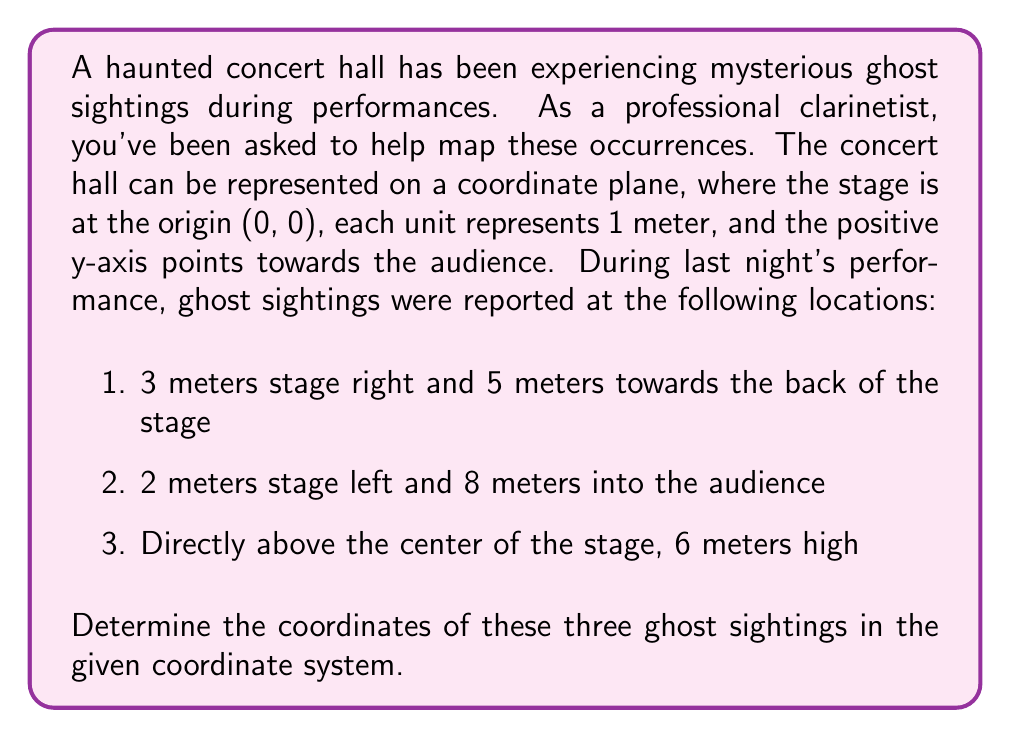Teach me how to tackle this problem. To solve this problem, we need to understand how the coordinate system is set up and translate the given information into coordinates. Let's break it down step-by-step:

1. The stage is at the origin (0, 0).
2. Each unit represents 1 meter.
3. The positive y-axis points towards the audience.
4. Stage right is in the negative x direction, and stage left is in the positive x direction.
5. Towards the back of the stage is in the negative y direction.
6. Height is represented by the z-axis.

Now, let's determine the coordinates for each sighting:

1. 3 meters stage right and 5 meters towards the back of the stage:
   x = -3 (stage right is negative)
   y = -5 (back of stage is negative)
   z = 0 (no height mentioned)
   Coordinates: $(-3, -5, 0)$

2. 2 meters stage left and 8 meters into the audience:
   x = 2 (stage left is positive)
   y = 8 (audience direction is positive)
   z = 0 (no height mentioned)
   Coordinates: $(2, 8, 0)$

3. Directly above the center of the stage, 6 meters high:
   x = 0 (center of stage, no horizontal displacement)
   y = 0 (center of stage, no forward/backward displacement)
   z = 6 (6 meters high)
   Coordinates: $(0, 0, 6)$

Therefore, the three ghost sightings can be represented by the following coordinates:
$(-3, -5, 0)$, $(2, 8, 0)$, and $(0, 0, 6)$.
Answer: The coordinates of the three ghost sightings are:
1. $(-3, -5, 0)$
2. $(2, 8, 0)$
3. $(0, 0, 6)$ 